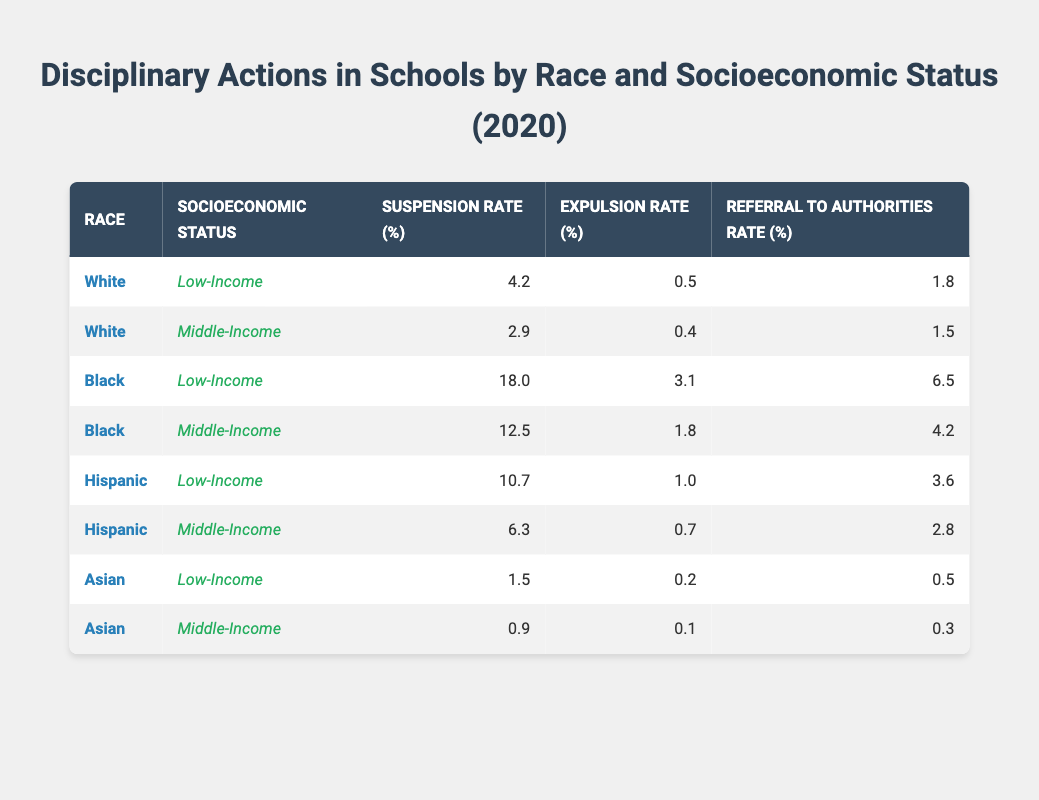What is the suspension rate for Black students from low-income backgrounds? Referring to the table, the suspension rate for Black students who are low-income is listed under their respective row. The rate is clearly given as 18.0%.
Answer: 18.0% What is the expulsion rate for Hispanic students who are middle-income? In the table, you can find the row for Hispanic students with middle-income, which shows their expulsion rate as 0.7%.
Answer: 0.7% Are Asian students from low-income backgrounds more frequently suspended than Hispanic students from low-income backgrounds? The suspension rate for Asian students from low-income backgrounds is 1.5%, while for Hispanic students it is 10.7%. Since 1.5% is less than 10.7%, Asian students are suspended less frequently than Hispanic students in this category.
Answer: No What is the difference in the referral to authorities rate between Black students from low-income and white students from low-income backgrounds? The referral to authorities rate for Black students who are low-income is 6.5%, while for White students it is 1.8%. The difference is calculated by subtracting the two rates: 6.5% - 1.8% = 4.7%.
Answer: 4.7% Calculate the average suspension rate for all racial groups with middle-income status. The suspension rates for middle-income are as follows: White: 2.9%, Black: 12.5%, Hispanic: 6.3%, Asian: 0.9%. To find the average, sum these values: 2.9 + 12.5 + 6.3 + 0.9 = 22.6. Then, divide by the number of groups: 22.6 / 4 = 5.65%.
Answer: 5.65% Is the referral to authorities rate for low-income Black students higher than that for low-income Asian students? From the table, the referral to authorities rate for low-income Black students is 6.5%, while for low-income Asian students, it is 0.5%. Since 6.5% is greater than 0.5%, the answer is yes.
Answer: Yes What is the most concerning disciplinary action (highest rate) for low-income Black students based on the data? In the data, the most concerning disciplinary action for low-income Black students is the suspension rate, which is the highest at 18.0% compared to expulsion and referral rates.
Answer: Suspension Which racial group has the lowest expulsion rate among middle-income students? Looking at the expulsion rates for middle-income students, White has 0.4%, Black has 1.8%, Hispanic has 0.7%, and Asian has 0.1%. Asian students have the lowest expulsion rate of 0.1%.
Answer: Asian What is the combined suspension rate for low-income students across all racial groups? The combined suspension rates for low-income students are: White: 4.2%, Black: 18.0%, Hispanic: 10.7%, Asian: 1.5%. The total is calculated as 4.2 + 18.0 + 10.7 + 1.5 = 34.4%.
Answer: 34.4% 